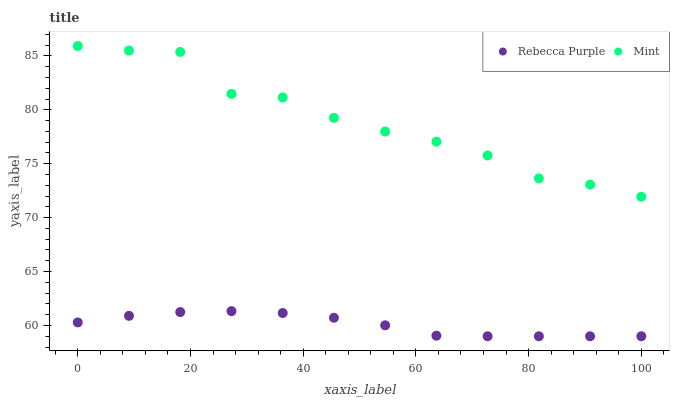Does Rebecca Purple have the minimum area under the curve?
Answer yes or no. Yes. Does Mint have the maximum area under the curve?
Answer yes or no. Yes. Does Rebecca Purple have the maximum area under the curve?
Answer yes or no. No. Is Rebecca Purple the smoothest?
Answer yes or no. Yes. Is Mint the roughest?
Answer yes or no. Yes. Is Rebecca Purple the roughest?
Answer yes or no. No. Does Rebecca Purple have the lowest value?
Answer yes or no. Yes. Does Mint have the highest value?
Answer yes or no. Yes. Does Rebecca Purple have the highest value?
Answer yes or no. No. Is Rebecca Purple less than Mint?
Answer yes or no. Yes. Is Mint greater than Rebecca Purple?
Answer yes or no. Yes. Does Rebecca Purple intersect Mint?
Answer yes or no. No. 